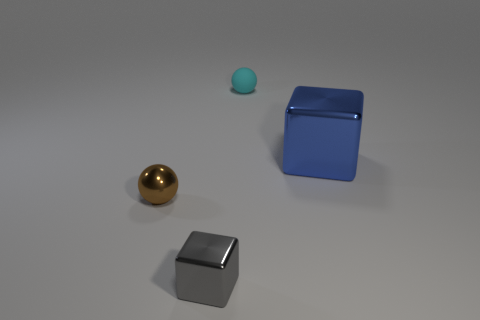Add 3 small metallic spheres. How many objects exist? 7 Subtract all cyan spheres. Subtract all gray cubes. How many spheres are left? 1 Subtract all red cylinders. How many blue cubes are left? 1 Subtract all tiny brown spheres. Subtract all big blue cubes. How many objects are left? 2 Add 3 tiny gray things. How many tiny gray things are left? 4 Add 3 big things. How many big things exist? 4 Subtract 0 cyan cylinders. How many objects are left? 4 Subtract 2 cubes. How many cubes are left? 0 